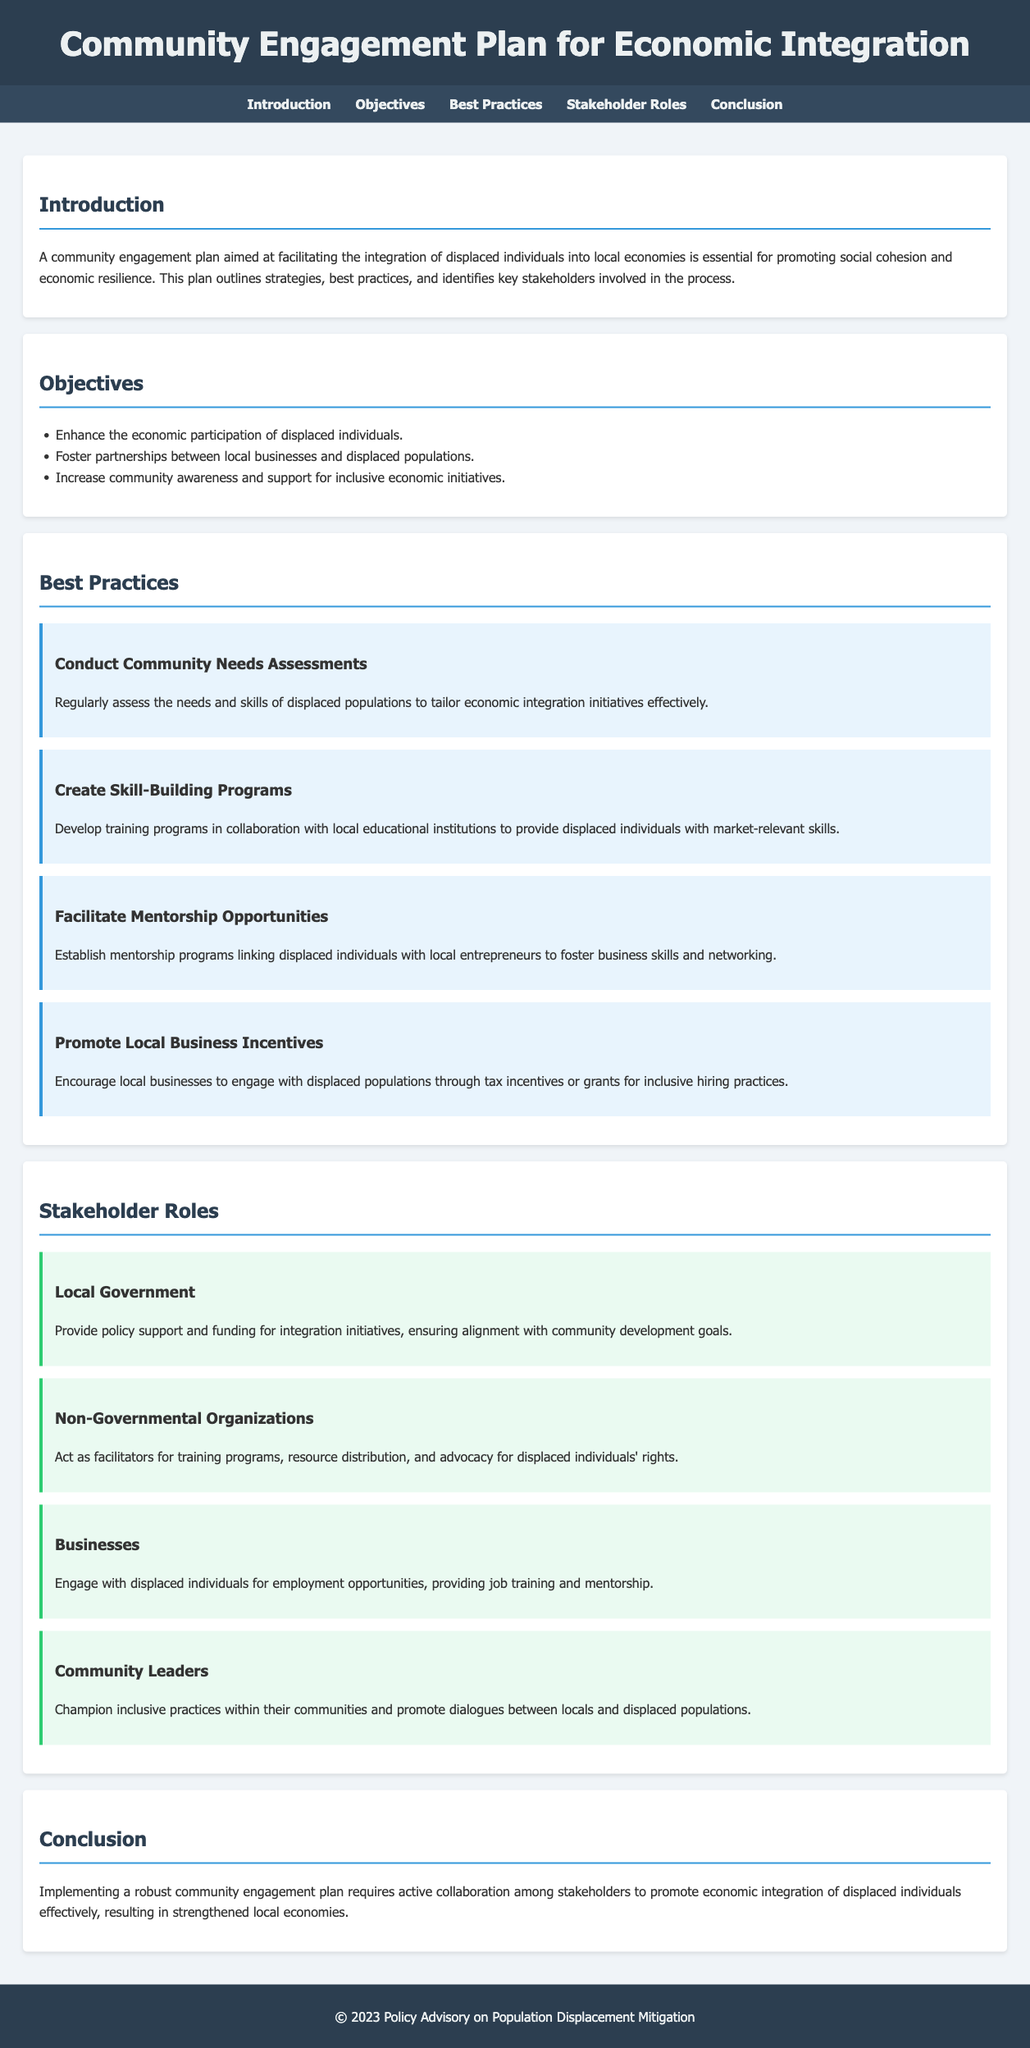What is the title of the document? The title is prominently displayed in the header section of the document.
Answer: Community Engagement Plan for Economic Integration What is the first objective listed in the document? The objectives are found in the corresponding section, where the first item is listed.
Answer: Enhance the economic participation of displaced individuals What is one of the best practices mentioned for integrating displaced individuals? The best practices section outlines various strategies; one specific example is highlighted.
Answer: Conduct Community Needs Assessments Who is responsible for providing policy support according to the stakeholder roles? The stakeholder roles section delineates responsibilities; local government is noted.
Answer: Local Government How many best practices are outlined in the document? The best practices section lists several strategies; counting them provides the answer.
Answer: Four What role do Non-Governmental Organizations play? This role is described in the stakeholder roles section, providing insights into their functions.
Answer: Facilitate training programs What is the purpose of the community engagement plan? The introduction specifies the primary aim of the plan.
Answer: Facilitate the integration of displaced individuals into local economies What incentive is suggested for local businesses? The best practices section discusses incentives that could encourage local businesses.
Answer: Tax incentives or grants for inclusive hiring practices What is the conclusion's emphasis regarding stakeholder collaboration? The conclusion summarizes the key takeaway of collaborative efforts among stakeholders.
Answer: Promote economic integration of displaced individuals effectively 